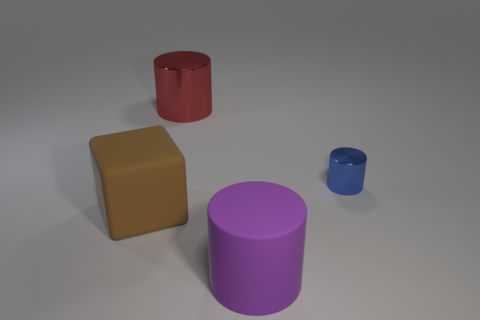Add 2 blue objects. How many objects exist? 6 Subtract all cylinders. How many objects are left? 1 Add 3 small purple metal cubes. How many small purple metal cubes exist? 3 Subtract 0 red spheres. How many objects are left? 4 Subtract all large rubber blocks. Subtract all big cyan spheres. How many objects are left? 3 Add 3 large cylinders. How many large cylinders are left? 5 